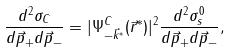<formula> <loc_0><loc_0><loc_500><loc_500>\frac { d ^ { 2 } \sigma _ { C } } { d \vec { p } _ { + } d \vec { p } _ { - } } = | \Psi _ { - \vec { k } ^ { * } } ^ { C } ( \vec { r } ^ { * } ) | ^ { 2 } \frac { d ^ { 2 } \sigma ^ { 0 } _ { s } } { d \vec { p } _ { + } d \vec { p } _ { - } } ,</formula> 